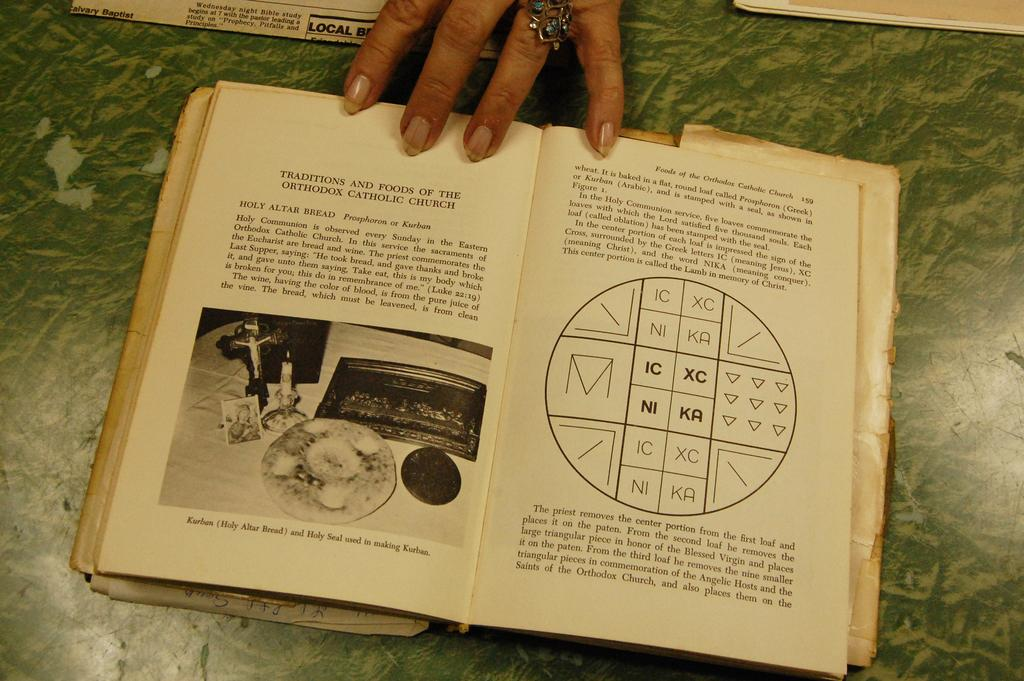<image>
Write a terse but informative summary of the picture. A book opened to a section about Traditions and Foods of the Orthodox Catholic Church. 